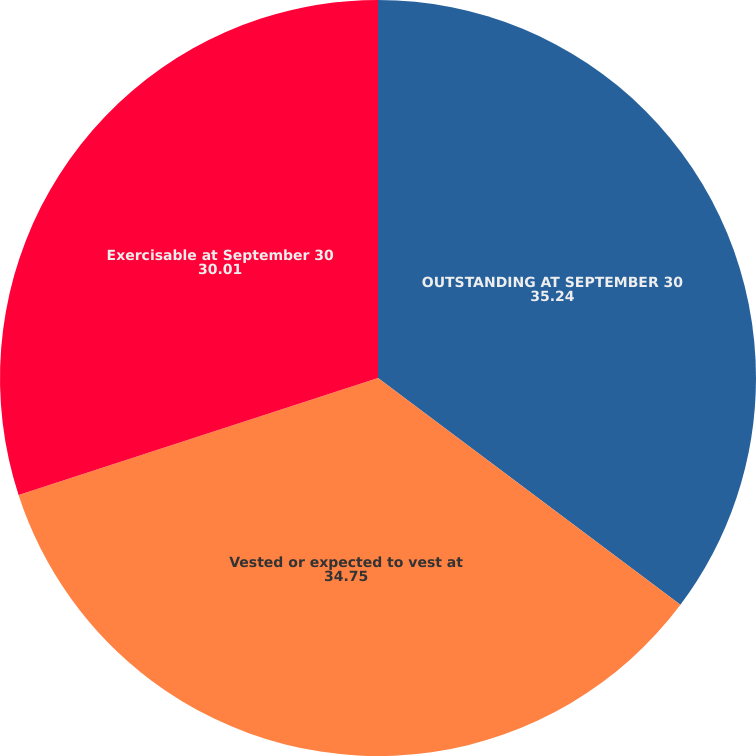Convert chart to OTSL. <chart><loc_0><loc_0><loc_500><loc_500><pie_chart><fcel>OUTSTANDING AT SEPTEMBER 30<fcel>Vested or expected to vest at<fcel>Exercisable at September 30<nl><fcel>35.24%<fcel>34.75%<fcel>30.01%<nl></chart> 